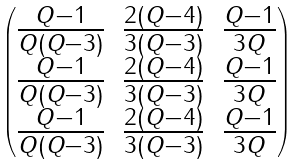Convert formula to latex. <formula><loc_0><loc_0><loc_500><loc_500>\begin{pmatrix} \frac { Q - 1 } { Q ( Q - 3 ) } & \frac { 2 ( Q - 4 ) } { 3 ( Q - 3 ) } & \frac { Q - 1 } { 3 Q } \\ \frac { Q - 1 } { Q ( Q - 3 ) } & \frac { 2 ( Q - 4 ) } { 3 ( Q - 3 ) } & \frac { Q - 1 } { 3 Q } \\ \frac { Q - 1 } { Q ( Q - 3 ) } & \frac { 2 ( Q - 4 ) } { 3 ( Q - 3 ) } & \frac { Q - 1 } { 3 Q } \end{pmatrix}</formula> 